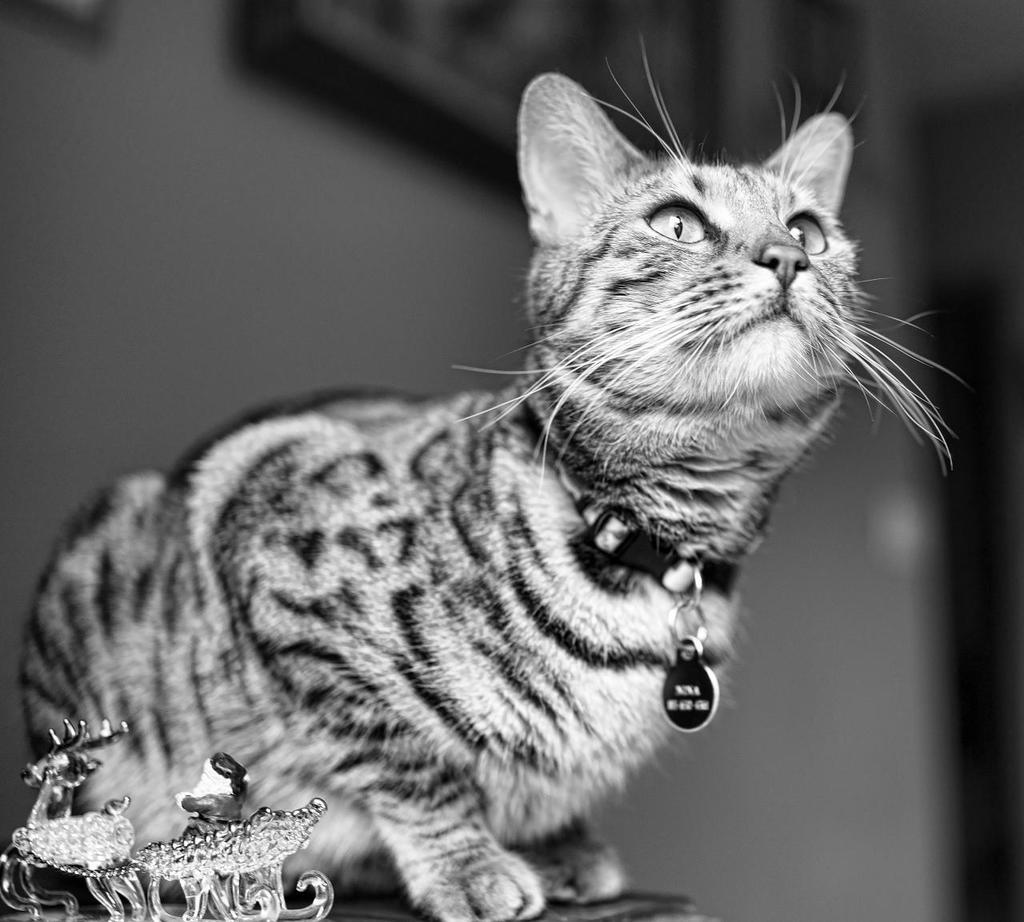What type of animal can be seen in the image? There is a cat in the image. What object is located in the bottom left of the image? There is a statue in the bottom left of the image. How would you describe the background of the image? The background of the image is blurry. What type of artwork is present on the wall in the image? There is a painting on the wall in the image. What type of bells can be heard ringing in the image? There are no bells present in the image, and therefore no sound can be heard. 